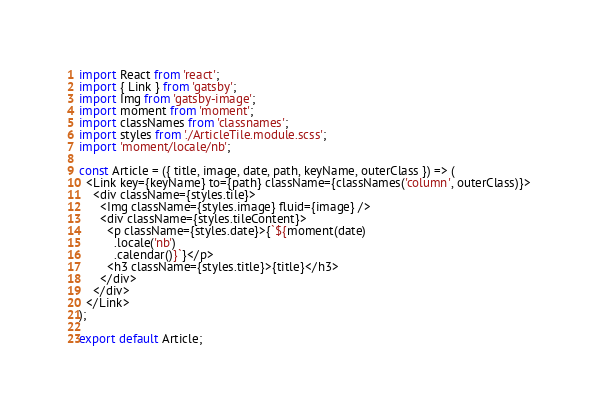<code> <loc_0><loc_0><loc_500><loc_500><_JavaScript_>import React from 'react';
import { Link } from 'gatsby';
import Img from 'gatsby-image';
import moment from 'moment';
import classNames from 'classnames';
import styles from './ArticleTile.module.scss';
import 'moment/locale/nb';

const Article = ({ title, image, date, path, keyName, outerClass }) => (
  <Link key={keyName} to={path} className={classNames('column', outerClass)}>
    <div className={styles.tile}>
      <Img className={styles.image} fluid={image} />
      <div className={styles.tileContent}>
        <p className={styles.date}>{`${moment(date)
          .locale('nb')
          .calendar()}`}</p>
        <h3 className={styles.title}>{title}</h3>
      </div>
    </div>
  </Link>
);

export default Article;
</code> 